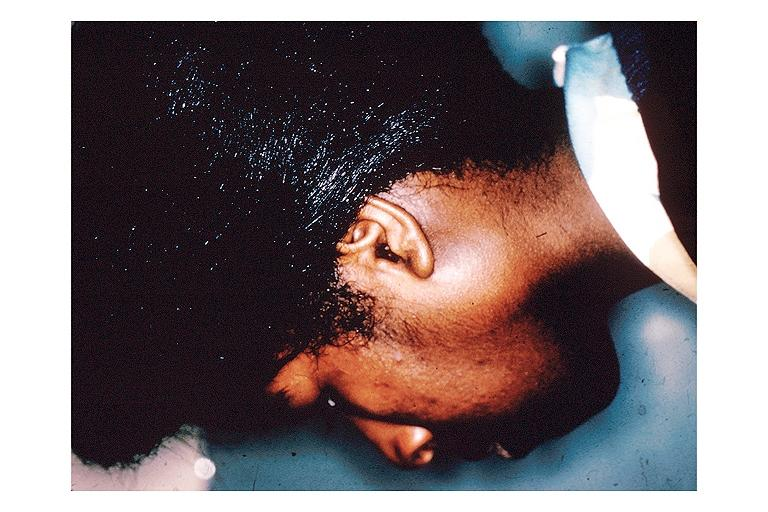does this image show sarcoidosis?
Answer the question using a single word or phrase. Yes 